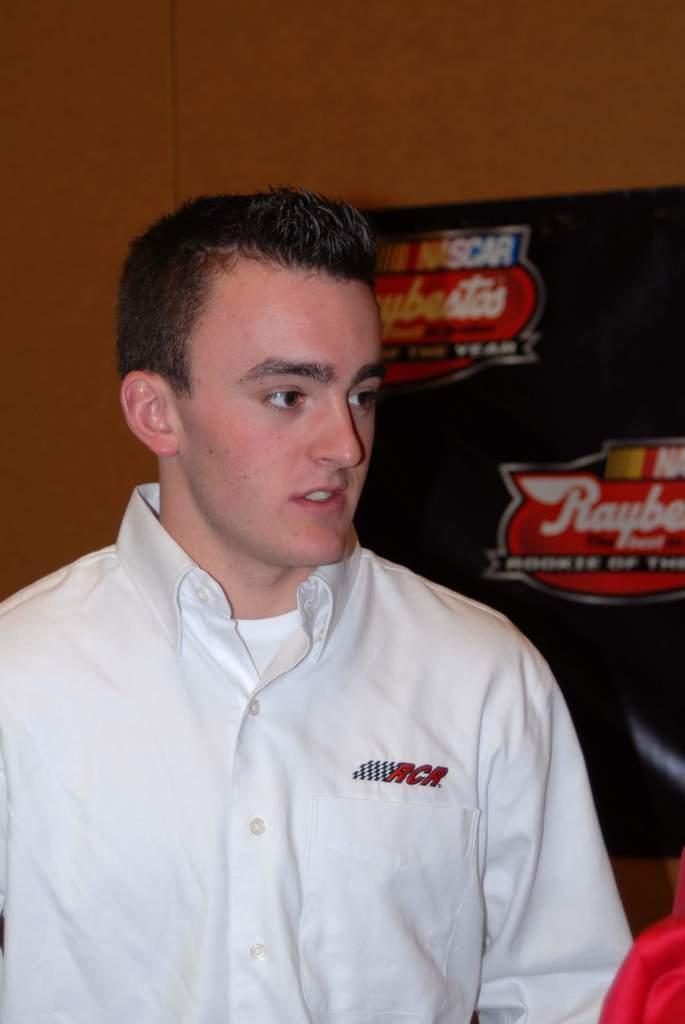<image>
Present a compact description of the photo's key features. RCR is patched onto this person's polo shirt. 